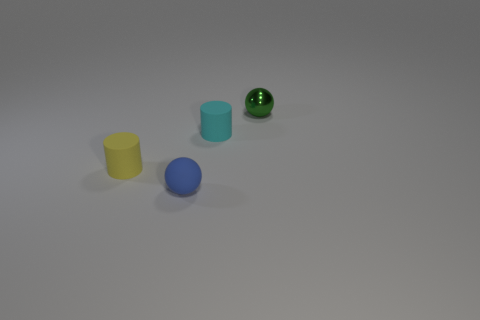Can you describe the arrangement of objects based on their colors? Sure! Starting from the left, there is a yellow cylinder, a blue sphere, a cyan cube, and a green speckled sphere. 